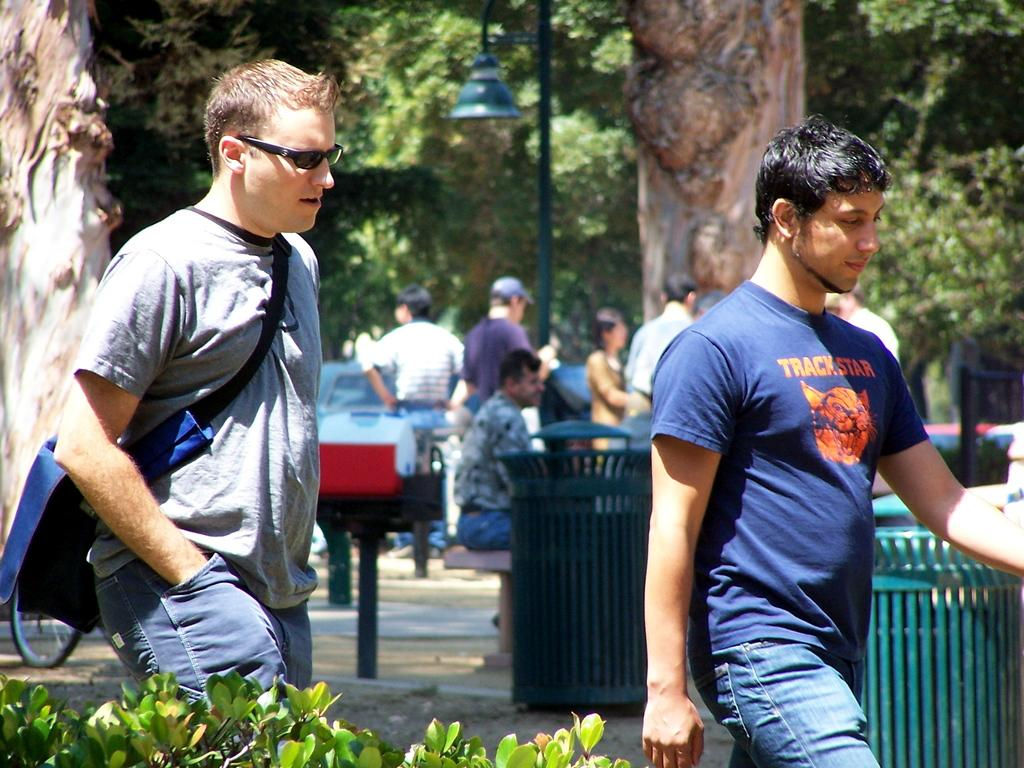Who or what can be seen in the image? There are people in the image. What type of natural elements are present in the image? There are trees and plants in the image. What structures can be seen in the image? There are poles and a fence in the image. What artificial light source is visible in the image? There is a light in the image. What mode of transportation is present in the image? There is a vehicle in the image. What type of robin can be seen perched on the fence in the image? There is no robin present in the image; it only features people, trees, plants, poles, a fence, a light, and a vehicle. 